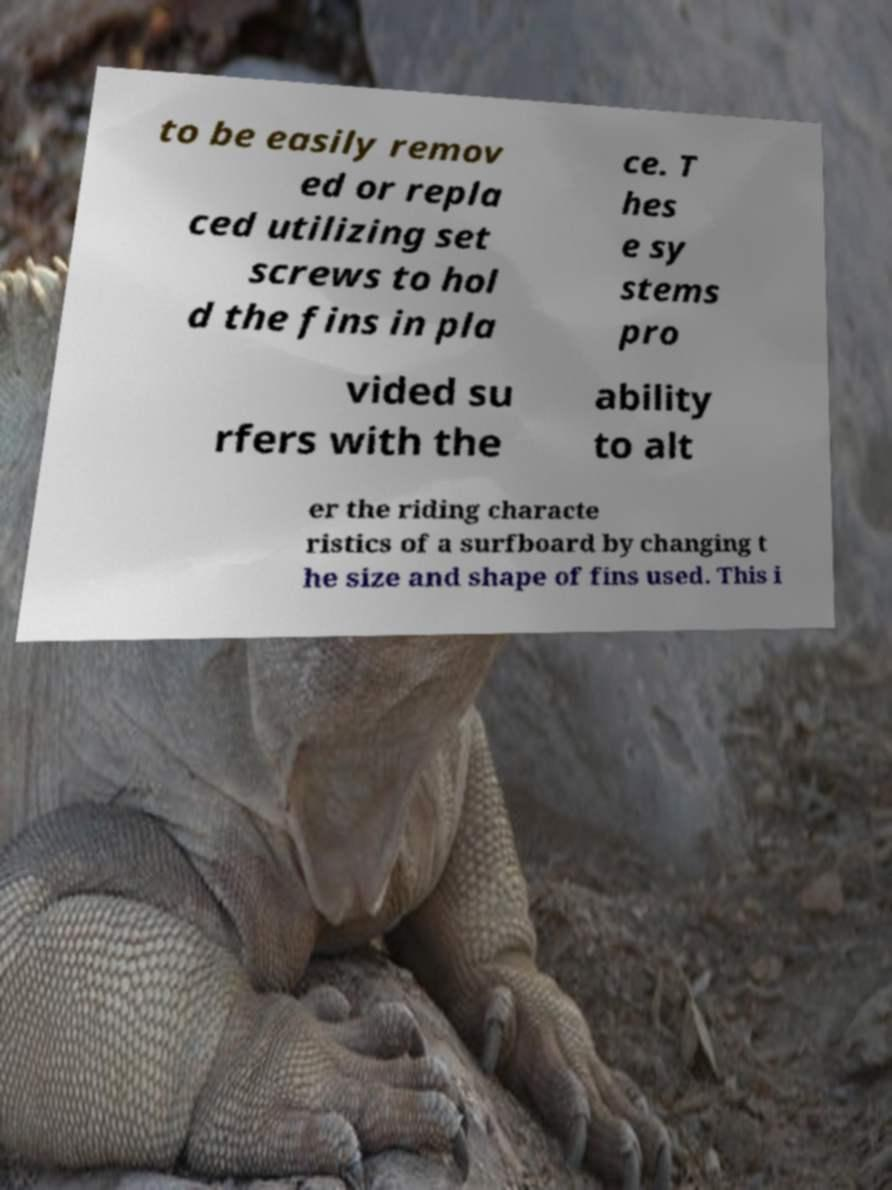Please identify and transcribe the text found in this image. to be easily remov ed or repla ced utilizing set screws to hol d the fins in pla ce. T hes e sy stems pro vided su rfers with the ability to alt er the riding characte ristics of a surfboard by changing t he size and shape of fins used. This i 